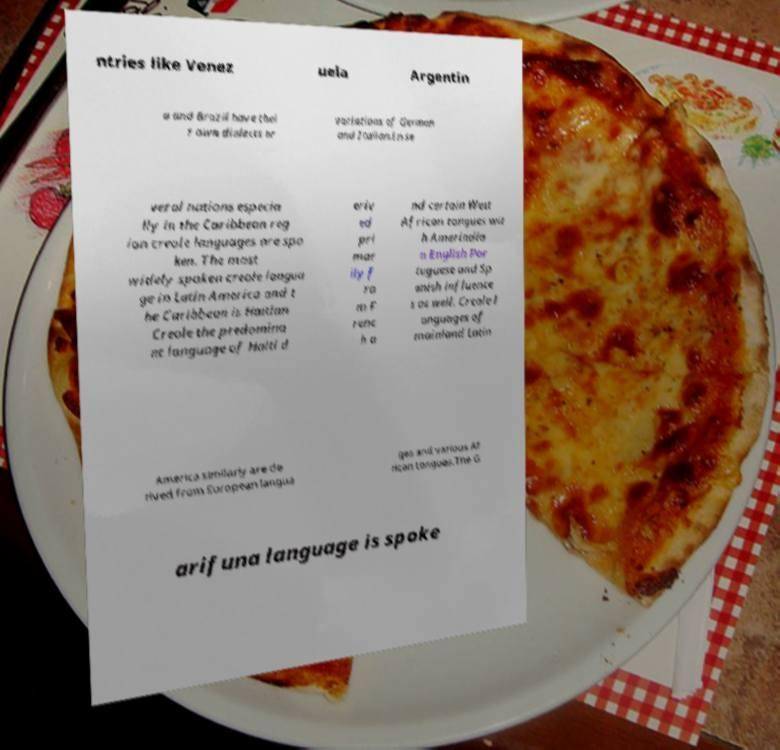For documentation purposes, I need the text within this image transcribed. Could you provide that? ntries like Venez uela Argentin a and Brazil have thei r own dialects or variations of German and Italian.In se veral nations especia lly in the Caribbean reg ion creole languages are spo ken. The most widely spoken creole langua ge in Latin America and t he Caribbean is Haitian Creole the predomina nt language of Haiti d eriv ed pri mar ily f ro m F renc h a nd certain West African tongues wit h Amerindia n English Por tuguese and Sp anish influence s as well. Creole l anguages of mainland Latin America similarly are de rived from European langua ges and various Af rican tongues.The G arifuna language is spoke 